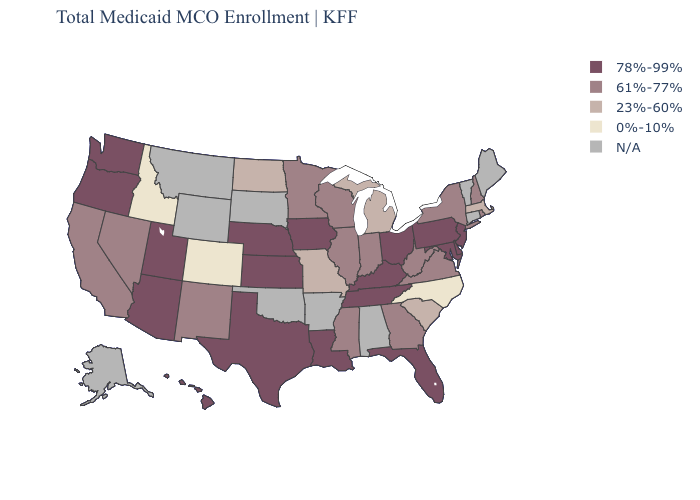What is the value of Nebraska?
Quick response, please. 78%-99%. Which states have the lowest value in the Northeast?
Write a very short answer. Massachusetts. Which states have the lowest value in the Northeast?
Be succinct. Massachusetts. Among the states that border North Carolina , which have the lowest value?
Be succinct. South Carolina. What is the highest value in the Northeast ?
Answer briefly. 78%-99%. What is the lowest value in states that border Utah?
Short answer required. 0%-10%. What is the highest value in the USA?
Quick response, please. 78%-99%. What is the value of New Hampshire?
Short answer required. 61%-77%. Does Kansas have the highest value in the USA?
Keep it brief. Yes. What is the highest value in the South ?
Concise answer only. 78%-99%. What is the highest value in the USA?
Short answer required. 78%-99%. Name the states that have a value in the range 23%-60%?
Quick response, please. Massachusetts, Michigan, Missouri, North Dakota, South Carolina. What is the value of Utah?
Concise answer only. 78%-99%. Does Colorado have the lowest value in the West?
Quick response, please. Yes. 